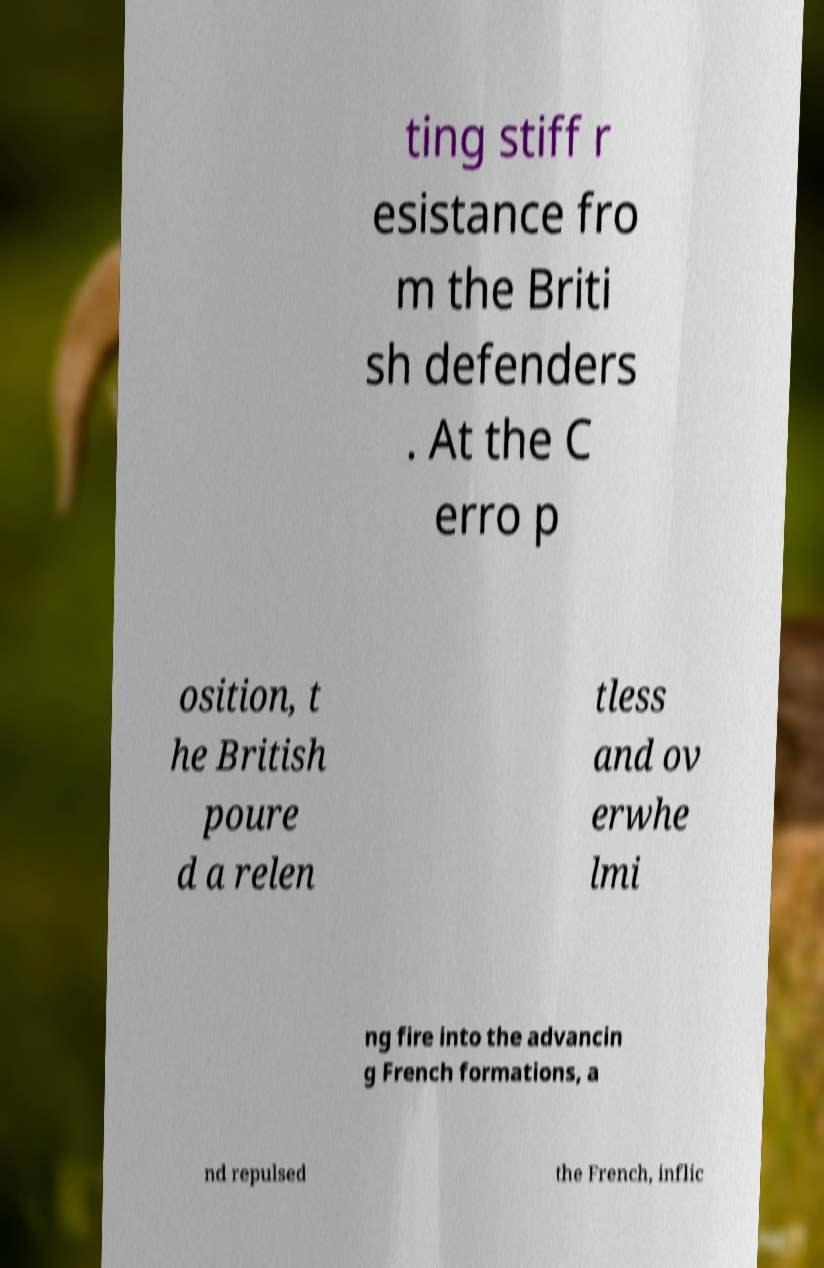Please identify and transcribe the text found in this image. ting stiff r esistance fro m the Briti sh defenders . At the C erro p osition, t he British poure d a relen tless and ov erwhe lmi ng fire into the advancin g French formations, a nd repulsed the French, inflic 